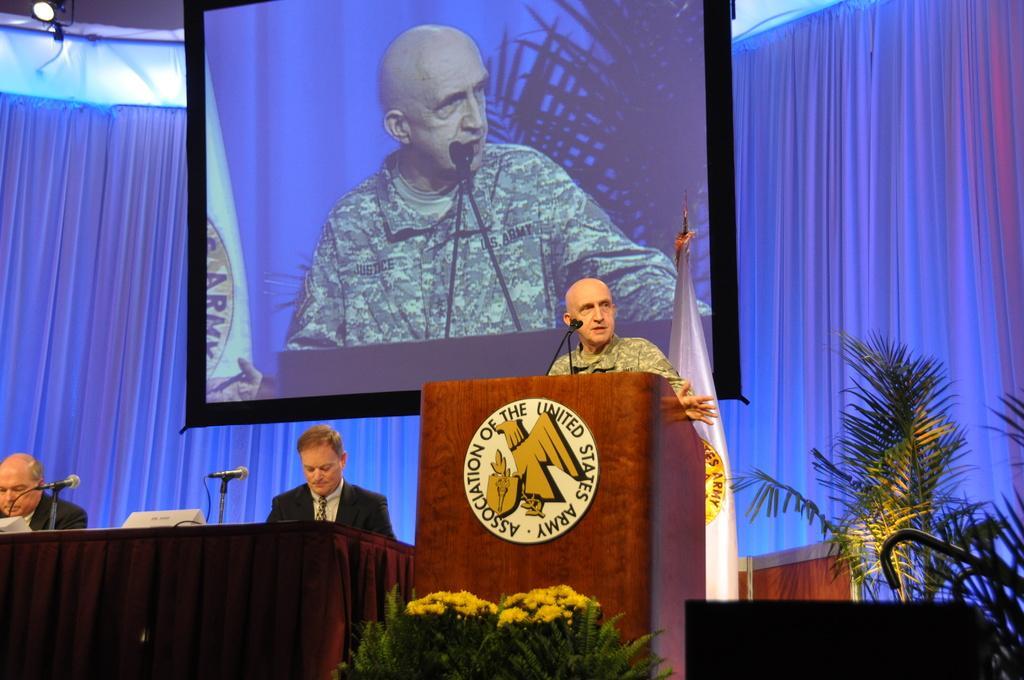Can you describe this image briefly? In this image I can see on the left side two persons are there, they wore coats, ties, shirts. In the middle a man is standing near the podium and speaking. He wore an army dress, behind him there is a projected screen. On the right side there are plants in this image. 